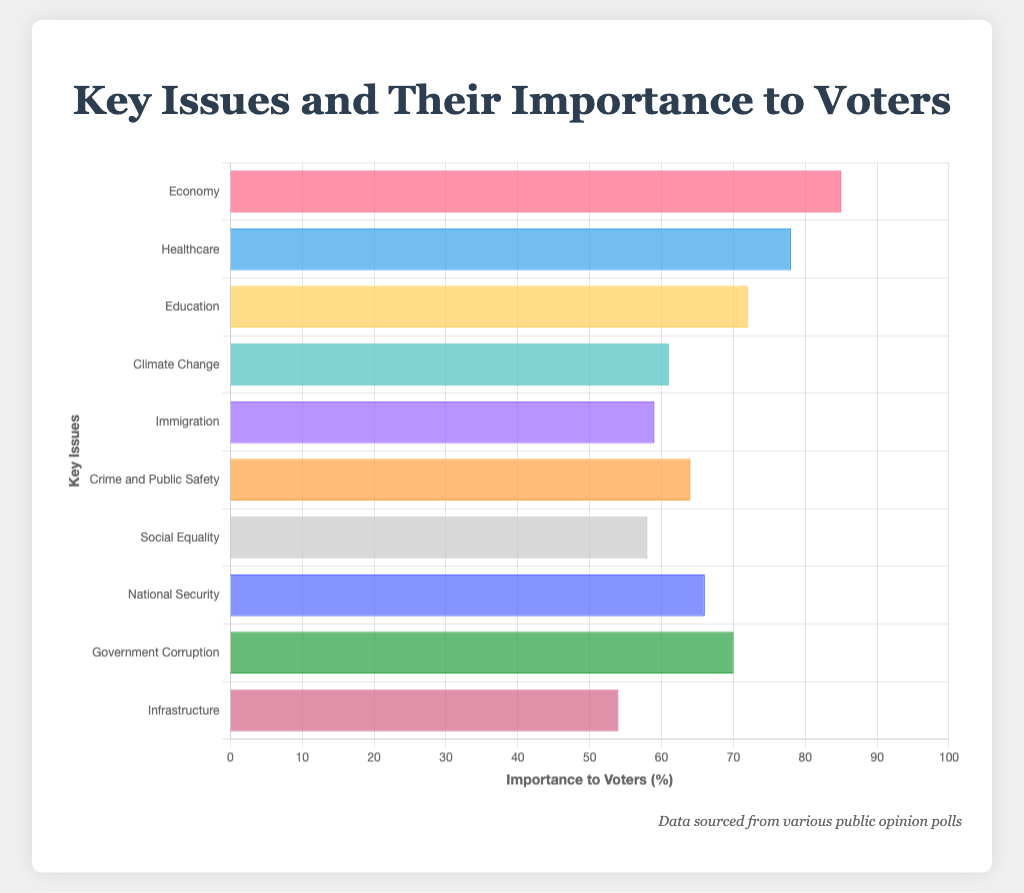What's the most important issue to voters? The figure shows the importance percentages for several key issues. The highest bar represents the most important issue. The Economy issue has the highest percentage at 85%.
Answer: Economy Which issue is considered more important: Crime and Public Safety or Climate Change? By comparing the heights of the bars for "Crime and Public Safety" and "Climate Change," we see that Crime and Public Safety has a higher percentage (64%) compared to Climate Change (61%).
Answer: Crime and Public Safety What is the combined percentage importance of Education and Government Corruption? The importance percentage for Education is 72% and for Government Corruption is 70%. Adding these together gives 72 + 70 = 142.
Answer: 142 Which issue has the least importance to voters according to the figure? By looking at the shortest bar in the figure, Infrastructure has the least importance with a percentage of 54%.
Answer: Infrastructure Is the importance of Social Equality higher than Immigration? Comparing the bars for Social Equality and Immigration, Social Equality is 58% and Immigration is 59%. Hence, Social Equality is not higher than Immigration.
Answer: No What is the average importance percentage for the issues listed? To find the average, sum all percentages and divide by the number of issues: (85 + 78 + 72 + 61 + 59 + 64 + 58 + 66 + 70 + 54) / 10 = 667 / 10 = 66.7%
Answer: 66.7% Which issues have an importance percentage of more than 75%? Referring to the figure, the issues with percentage above 75% are Economy (85%) and Healthcare (78%).
Answer: Economy, Healthcare Which issue has a greater importance percentage: National Security or Social Equality? Comparing the bars for National Security (66%) and Social Equality (58%), National Security has a greater importance percentage.
Answer: National Security What is the percentage difference between Healthcare and Immigration? The importance percentage for Healthcare is 78% and for Immigration is 59%. The difference is 78 - 59 = 19%.
Answer: 19% How many issues have an importance percentage between 60% and 70%? The figure shows the bars for issues with percentages between 60% and 70%: Climate Change (61%), Crime and Public Safety (64%), National Security (66%), and Government Corruption (70%), making it 4 issues.
Answer: 4 